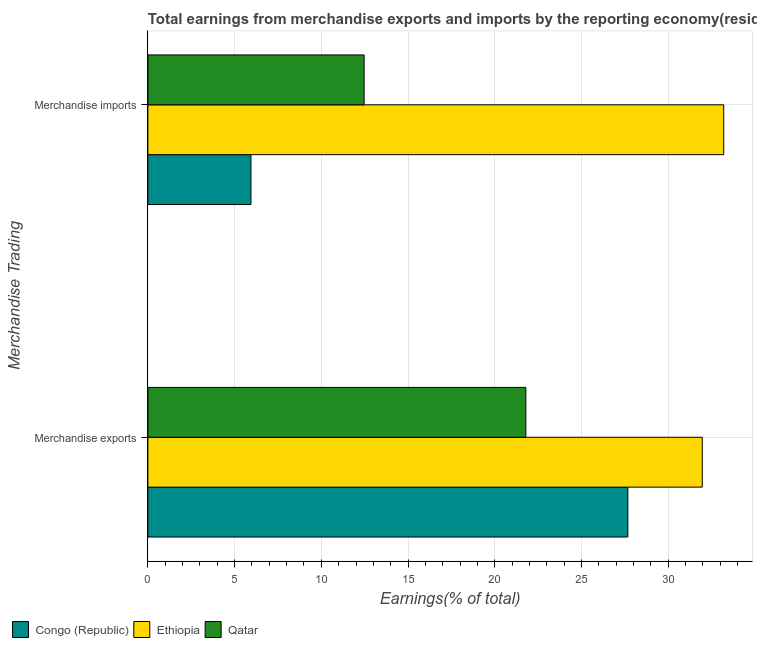How many groups of bars are there?
Ensure brevity in your answer.  2. How many bars are there on the 1st tick from the top?
Provide a short and direct response. 3. What is the label of the 2nd group of bars from the top?
Your response must be concise. Merchandise exports. What is the earnings from merchandise exports in Ethiopia?
Offer a terse response. 31.96. Across all countries, what is the maximum earnings from merchandise imports?
Provide a short and direct response. 33.2. Across all countries, what is the minimum earnings from merchandise imports?
Offer a terse response. 5.94. In which country was the earnings from merchandise exports maximum?
Offer a very short reply. Ethiopia. In which country was the earnings from merchandise exports minimum?
Offer a terse response. Qatar. What is the total earnings from merchandise exports in the graph?
Provide a short and direct response. 81.43. What is the difference between the earnings from merchandise exports in Congo (Republic) and that in Qatar?
Offer a very short reply. 5.88. What is the difference between the earnings from merchandise exports in Congo (Republic) and the earnings from merchandise imports in Qatar?
Offer a terse response. 15.21. What is the average earnings from merchandise imports per country?
Ensure brevity in your answer.  17.2. What is the difference between the earnings from merchandise imports and earnings from merchandise exports in Ethiopia?
Ensure brevity in your answer.  1.24. What is the ratio of the earnings from merchandise imports in Ethiopia to that in Congo (Republic)?
Your answer should be very brief. 5.59. Is the earnings from merchandise exports in Qatar less than that in Ethiopia?
Your answer should be very brief. Yes. What does the 3rd bar from the top in Merchandise exports represents?
Make the answer very short. Congo (Republic). What does the 2nd bar from the bottom in Merchandise exports represents?
Your response must be concise. Ethiopia. How many countries are there in the graph?
Your answer should be very brief. 3. What is the title of the graph?
Your answer should be compact. Total earnings from merchandise exports and imports by the reporting economy(residual) in 1980. What is the label or title of the X-axis?
Offer a terse response. Earnings(% of total). What is the label or title of the Y-axis?
Your response must be concise. Merchandise Trading. What is the Earnings(% of total) of Congo (Republic) in Merchandise exports?
Offer a very short reply. 27.67. What is the Earnings(% of total) in Ethiopia in Merchandise exports?
Make the answer very short. 31.96. What is the Earnings(% of total) in Qatar in Merchandise exports?
Give a very brief answer. 21.79. What is the Earnings(% of total) of Congo (Republic) in Merchandise imports?
Ensure brevity in your answer.  5.94. What is the Earnings(% of total) in Ethiopia in Merchandise imports?
Your response must be concise. 33.2. What is the Earnings(% of total) of Qatar in Merchandise imports?
Provide a succinct answer. 12.47. Across all Merchandise Trading, what is the maximum Earnings(% of total) in Congo (Republic)?
Offer a terse response. 27.67. Across all Merchandise Trading, what is the maximum Earnings(% of total) of Ethiopia?
Your response must be concise. 33.2. Across all Merchandise Trading, what is the maximum Earnings(% of total) of Qatar?
Your answer should be very brief. 21.79. Across all Merchandise Trading, what is the minimum Earnings(% of total) in Congo (Republic)?
Ensure brevity in your answer.  5.94. Across all Merchandise Trading, what is the minimum Earnings(% of total) of Ethiopia?
Your answer should be compact. 31.96. Across all Merchandise Trading, what is the minimum Earnings(% of total) of Qatar?
Provide a succinct answer. 12.47. What is the total Earnings(% of total) in Congo (Republic) in the graph?
Provide a short and direct response. 33.62. What is the total Earnings(% of total) in Ethiopia in the graph?
Your answer should be compact. 65.16. What is the total Earnings(% of total) in Qatar in the graph?
Your response must be concise. 34.26. What is the difference between the Earnings(% of total) in Congo (Republic) in Merchandise exports and that in Merchandise imports?
Offer a terse response. 21.73. What is the difference between the Earnings(% of total) of Ethiopia in Merchandise exports and that in Merchandise imports?
Provide a short and direct response. -1.24. What is the difference between the Earnings(% of total) of Qatar in Merchandise exports and that in Merchandise imports?
Make the answer very short. 9.32. What is the difference between the Earnings(% of total) of Congo (Republic) in Merchandise exports and the Earnings(% of total) of Ethiopia in Merchandise imports?
Your answer should be very brief. -5.53. What is the difference between the Earnings(% of total) in Congo (Republic) in Merchandise exports and the Earnings(% of total) in Qatar in Merchandise imports?
Offer a terse response. 15.21. What is the difference between the Earnings(% of total) of Ethiopia in Merchandise exports and the Earnings(% of total) of Qatar in Merchandise imports?
Offer a very short reply. 19.5. What is the average Earnings(% of total) in Congo (Republic) per Merchandise Trading?
Your answer should be compact. 16.81. What is the average Earnings(% of total) in Ethiopia per Merchandise Trading?
Offer a very short reply. 32.58. What is the average Earnings(% of total) in Qatar per Merchandise Trading?
Ensure brevity in your answer.  17.13. What is the difference between the Earnings(% of total) of Congo (Republic) and Earnings(% of total) of Ethiopia in Merchandise exports?
Ensure brevity in your answer.  -4.29. What is the difference between the Earnings(% of total) of Congo (Republic) and Earnings(% of total) of Qatar in Merchandise exports?
Give a very brief answer. 5.88. What is the difference between the Earnings(% of total) of Ethiopia and Earnings(% of total) of Qatar in Merchandise exports?
Offer a very short reply. 10.17. What is the difference between the Earnings(% of total) in Congo (Republic) and Earnings(% of total) in Ethiopia in Merchandise imports?
Provide a succinct answer. -27.26. What is the difference between the Earnings(% of total) of Congo (Republic) and Earnings(% of total) of Qatar in Merchandise imports?
Ensure brevity in your answer.  -6.52. What is the difference between the Earnings(% of total) of Ethiopia and Earnings(% of total) of Qatar in Merchandise imports?
Provide a succinct answer. 20.73. What is the ratio of the Earnings(% of total) in Congo (Republic) in Merchandise exports to that in Merchandise imports?
Make the answer very short. 4.66. What is the ratio of the Earnings(% of total) of Ethiopia in Merchandise exports to that in Merchandise imports?
Provide a succinct answer. 0.96. What is the ratio of the Earnings(% of total) in Qatar in Merchandise exports to that in Merchandise imports?
Give a very brief answer. 1.75. What is the difference between the highest and the second highest Earnings(% of total) of Congo (Republic)?
Offer a terse response. 21.73. What is the difference between the highest and the second highest Earnings(% of total) of Ethiopia?
Offer a terse response. 1.24. What is the difference between the highest and the second highest Earnings(% of total) in Qatar?
Give a very brief answer. 9.32. What is the difference between the highest and the lowest Earnings(% of total) in Congo (Republic)?
Ensure brevity in your answer.  21.73. What is the difference between the highest and the lowest Earnings(% of total) of Ethiopia?
Keep it short and to the point. 1.24. What is the difference between the highest and the lowest Earnings(% of total) of Qatar?
Provide a short and direct response. 9.32. 